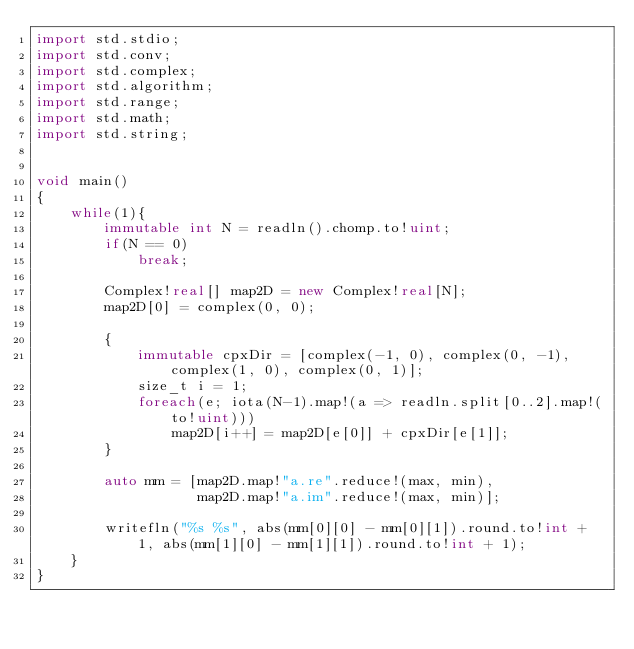Convert code to text. <code><loc_0><loc_0><loc_500><loc_500><_D_>import std.stdio;
import std.conv;
import std.complex;
import std.algorithm;
import std.range;
import std.math;
import std.string;


void main()
{
    while(1){
        immutable int N = readln().chomp.to!uint;
        if(N == 0)
            break;
 
        Complex!real[] map2D = new Complex!real[N];
        map2D[0] = complex(0, 0);
 
        {
            immutable cpxDir = [complex(-1, 0), complex(0, -1), complex(1, 0), complex(0, 1)];
            size_t i = 1;
            foreach(e; iota(N-1).map!(a => readln.split[0..2].map!(to!uint)))
                map2D[i++] = map2D[e[0]] + cpxDir[e[1]];
        }

        auto mm = [map2D.map!"a.re".reduce!(max, min),
                   map2D.map!"a.im".reduce!(max, min)];

        writefln("%s %s", abs(mm[0][0] - mm[0][1]).round.to!int + 1, abs(mm[1][0] - mm[1][1]).round.to!int + 1);
    }
}</code> 